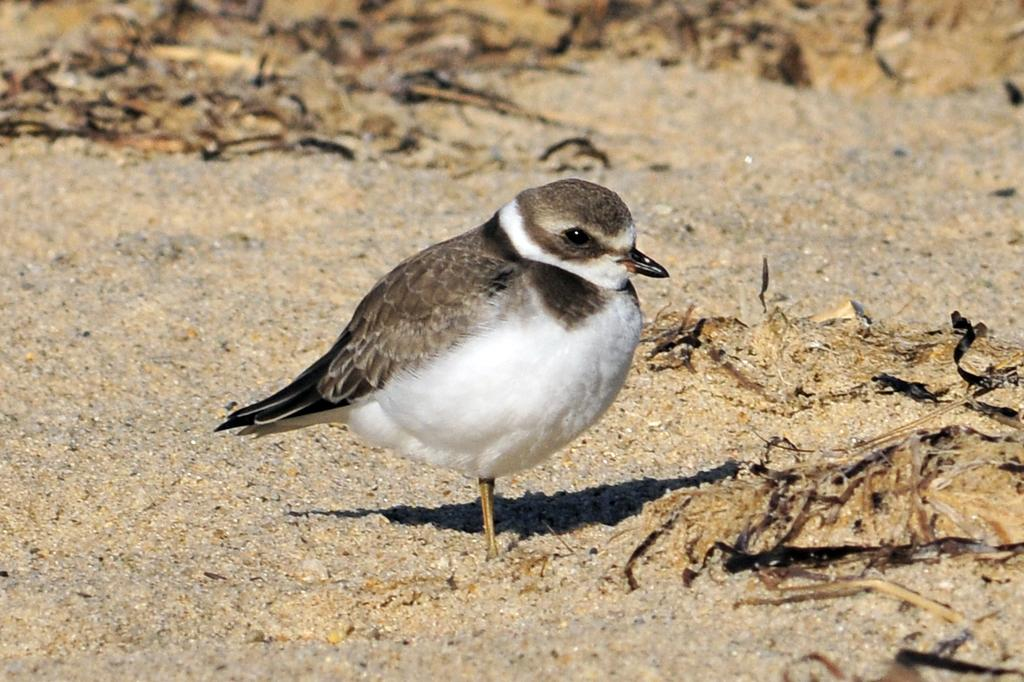What is the main subject of focus of the image? The main focus of the image is a bird. Where is the bird located in the image? The bird is in the middle of the image. What color pattern does the bird have? The bird has a white and black color pattern. What type of word is being spoken by the bird in the image? There is no indication that the bird is speaking any words in the image. 